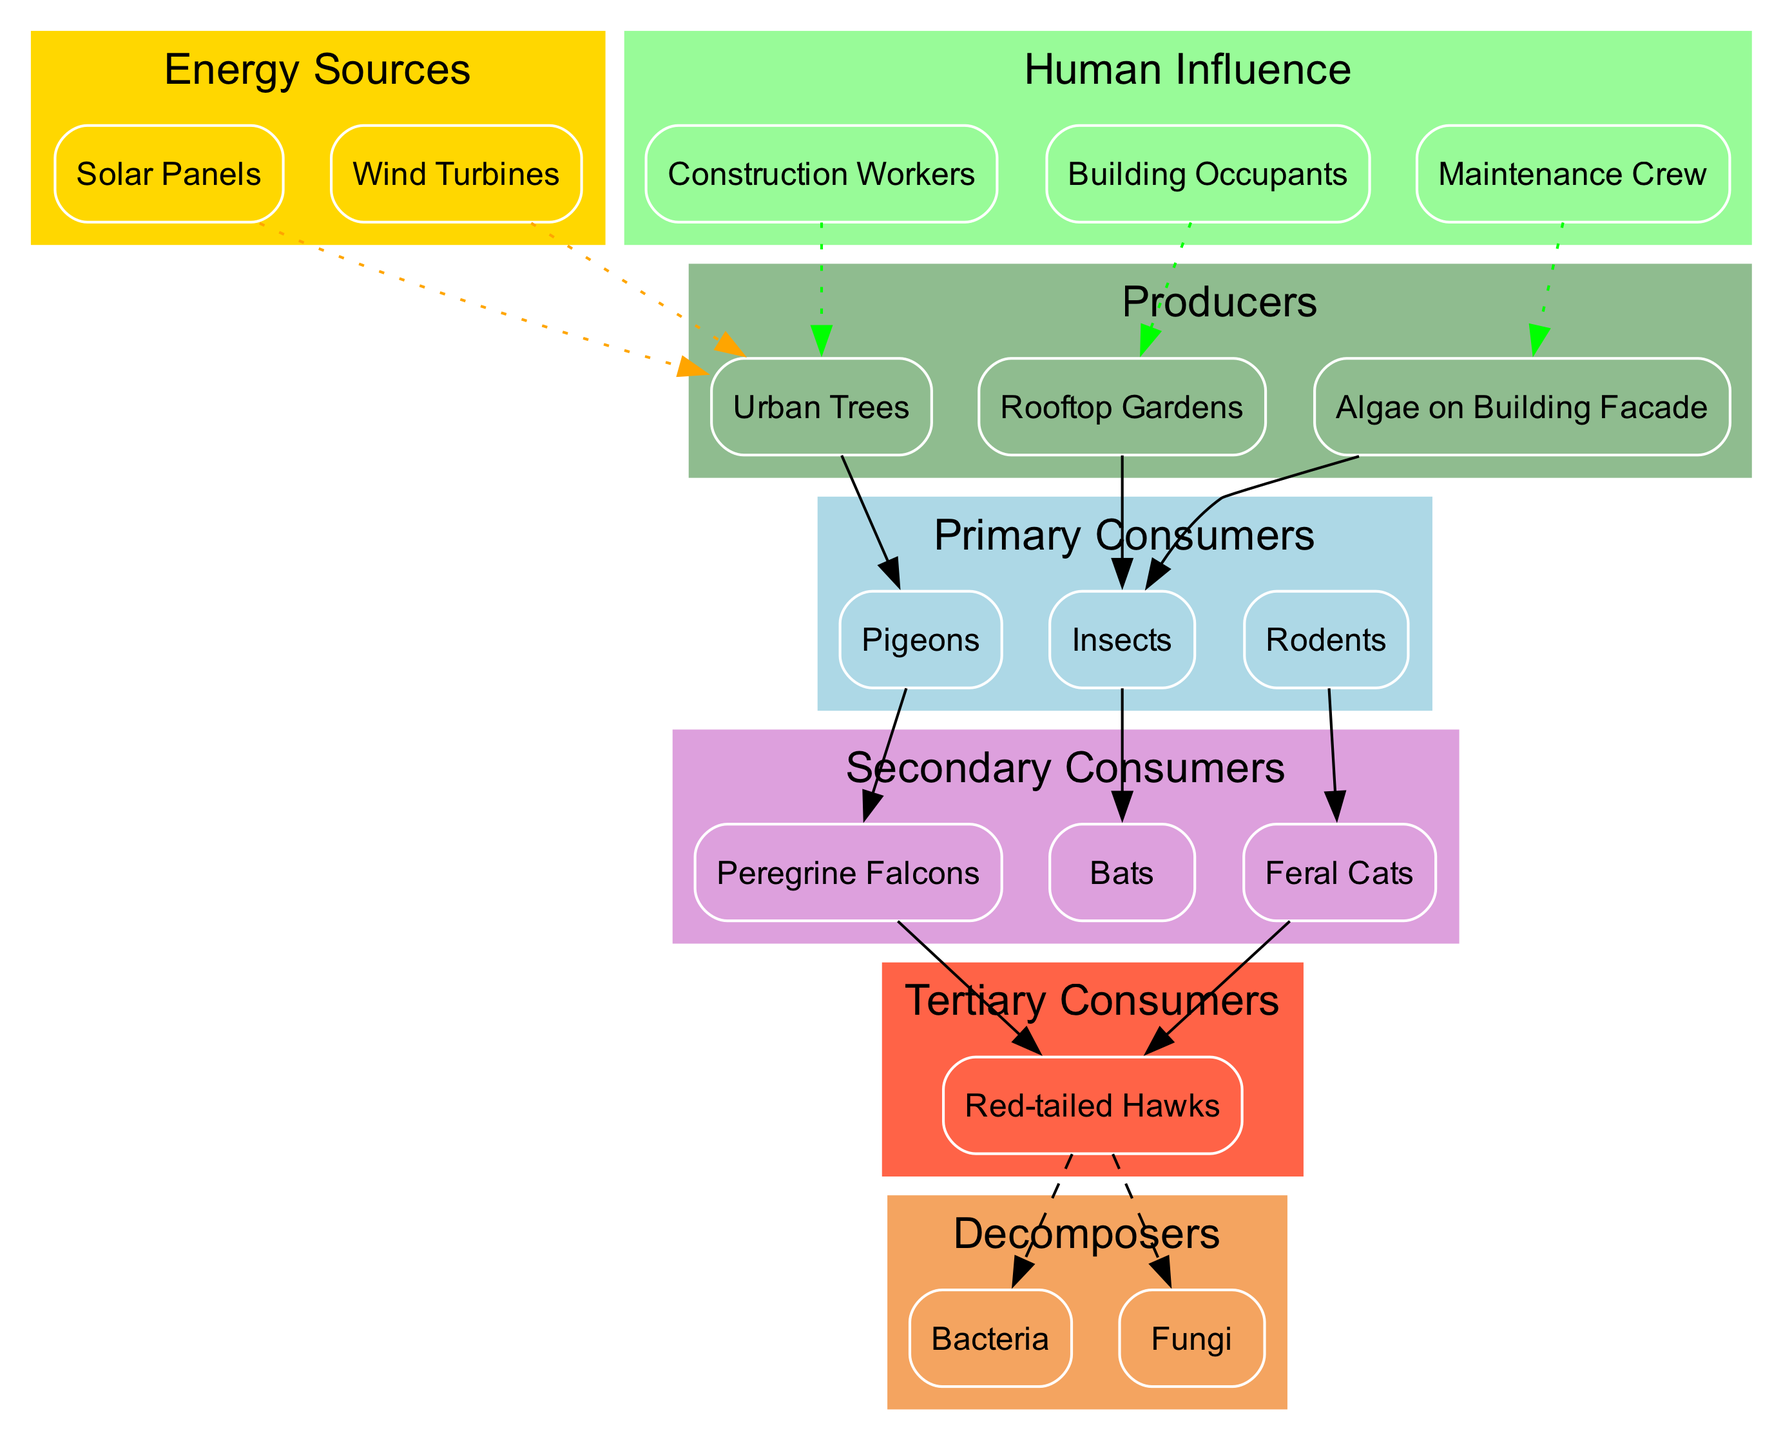What are the primary consumers in the urban ecosystem? The primary consumers are identified in the diagram as those that feed directly on the producers. By examining the nodes linked to the 'Urban Trees', 'Rooftop Gardens', and 'Algae on Building Facade', we see they connect to 'Pigeons', 'Insects', and 'Rodents', all noted as primary consumers.
Answer: Pigeons, Insects, Rodents How many producers are present in the diagram? The producers are listed in the 'producers' cluster, which includes 'Urban Trees', 'Rooftop Gardens', and 'Algae on Building Facade'. Counting these items results in a total of three producers.
Answer: 3 Which tertiary consumer is depicted in the diagram? The tertiary consumers can be identified by looking for nodes that receive energy from secondary consumers. Here, 'Red-tailed Hawks' is the node that receives energy from 'Peregrine Falcons' and 'Feral Cats', making it the only tertiary consumer in this food chain.
Answer: Red-tailed Hawks What energy sources are influencing the producers? The diagram shows edges with a dotted line leading from 'Solar Panels' and 'Wind Turbines' to 'Urban Trees', indicating that these energy sources directly influence or provide energy to the producer, 'Urban Trees'.
Answer: Solar Panels, Wind Turbines What do decomposers in the ecosystem connect to? In the diagram, decomposers are shown connected to 'Red-tailed Hawks' with a dashed line, indicating that they decompose the bodies of these tertiary consumers, thereby recycling energy back into the ecosystem.
Answer: Bacteria, Fungi Which secondary consumers are linked to which primary consumers? By analyzing the connections from primary to secondary consumers, 'Pigeons' lead to 'Peregrine Falcons', 'Insects' lead to 'Bats', and 'Rodents' lead to 'Feral Cats'. This shows the direct predation relationships in the food chain.
Answer: Peregrine Falcons, Bats, Feral Cats How many edges represent human influence in the food chain? Counting the dotted edges originating from nodes representing human influence ('Construction Workers', 'Building Occupants', and 'Maintenance Crew') to the producers, we find three distinct connections demonstrating human influence on the ecosystem.
Answer: 3 Which consumer connects to the greatest number of different food sources? By examining the connections of all consumer nodes, 'Red-tailed Hawks' connects to multiple secondary consumers such as 'Peregrine Falcons' and 'Feral Cats'. However, since it's only connected to these, it does not connect to a greater variety than the others. Hence, 'Pigeons', which links to 'Urban Trees', could be viewed favorably in this context.
Answer: Pigeons Which role does 'Bacteria' play in the urban food chain? 'Bacteria' is listed among the decomposers, shown by the dashed edges leading from 'Red-tailed Hawks'. This indicates that 'Bacteria' are responsible for breaking down organic matter from deceased organisms, thus playing a critical role in nutrient cycling within the ecosystem.
Answer: Decomposers 